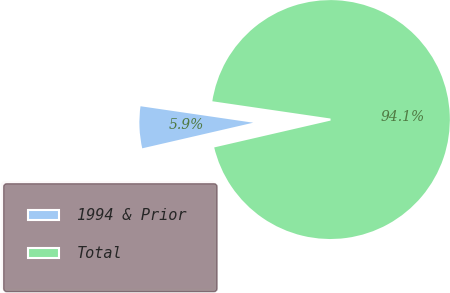Convert chart. <chart><loc_0><loc_0><loc_500><loc_500><pie_chart><fcel>1994 & Prior<fcel>Total<nl><fcel>5.92%<fcel>94.08%<nl></chart> 